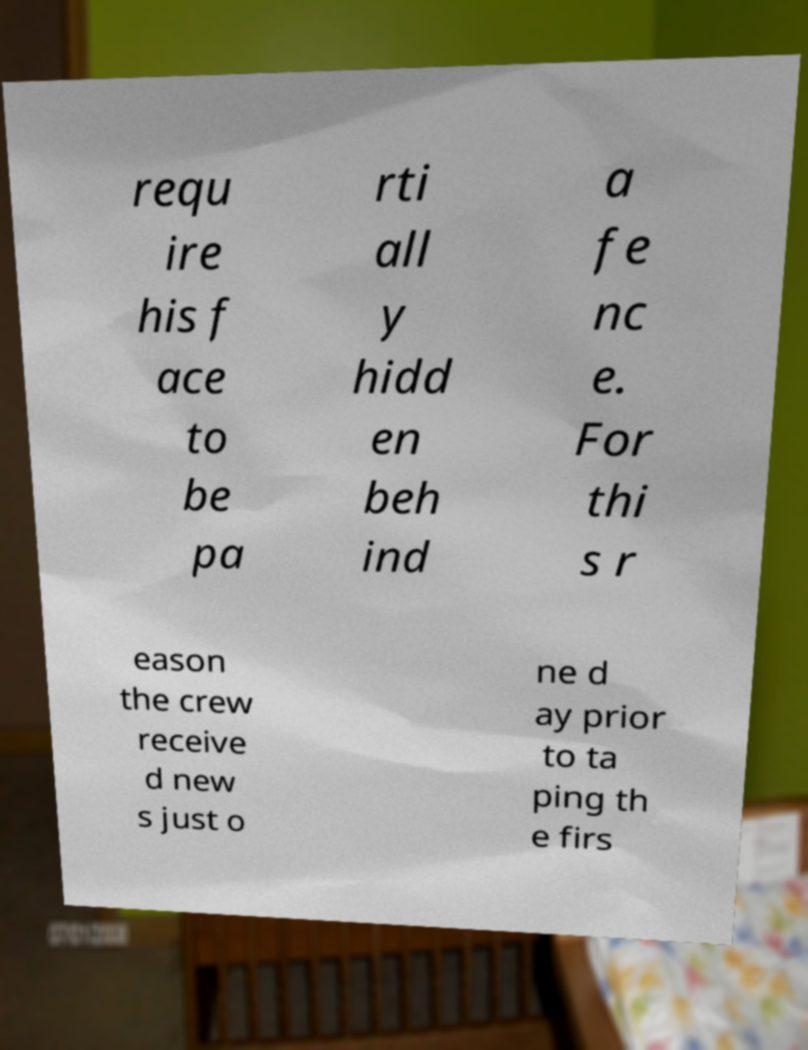There's text embedded in this image that I need extracted. Can you transcribe it verbatim? requ ire his f ace to be pa rti all y hidd en beh ind a fe nc e. For thi s r eason the crew receive d new s just o ne d ay prior to ta ping th e firs 